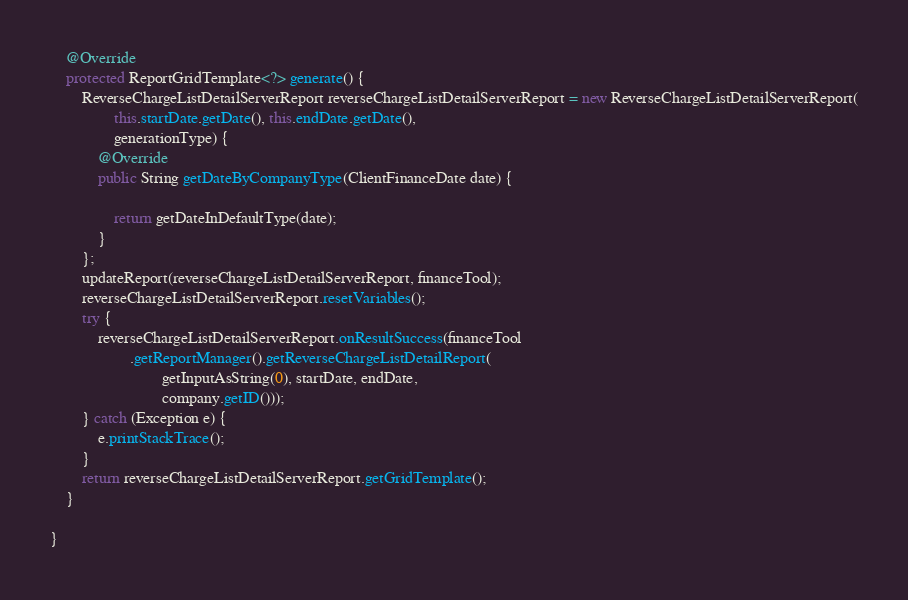Convert code to text. <code><loc_0><loc_0><loc_500><loc_500><_Java_>
	@Override
	protected ReportGridTemplate<?> generate() {
		ReverseChargeListDetailServerReport reverseChargeListDetailServerReport = new ReverseChargeListDetailServerReport(
				this.startDate.getDate(), this.endDate.getDate(),
				generationType) {
			@Override
			public String getDateByCompanyType(ClientFinanceDate date) {

				return getDateInDefaultType(date);
			}
		};
		updateReport(reverseChargeListDetailServerReport, financeTool);
		reverseChargeListDetailServerReport.resetVariables();
		try {
			reverseChargeListDetailServerReport.onResultSuccess(financeTool
					.getReportManager().getReverseChargeListDetailReport(
							getInputAsString(0), startDate, endDate,
							company.getID()));
		} catch (Exception e) {
			e.printStackTrace();
		}
		return reverseChargeListDetailServerReport.getGridTemplate();
	}

}
</code> 